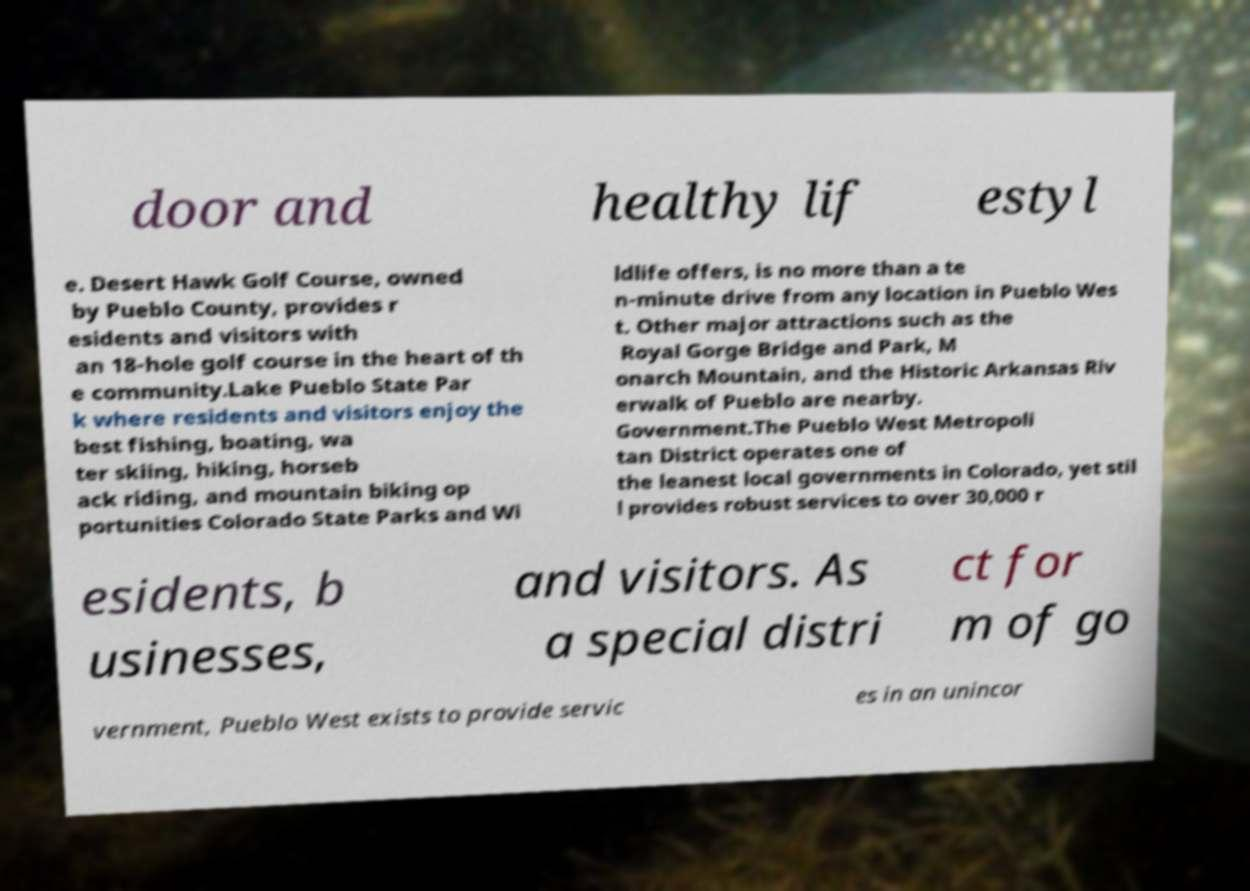What messages or text are displayed in this image? I need them in a readable, typed format. door and healthy lif estyl e. Desert Hawk Golf Course, owned by Pueblo County, provides r esidents and visitors with an 18-hole golf course in the heart of th e community.Lake Pueblo State Par k where residents and visitors enjoy the best fishing, boating, wa ter skiing, hiking, horseb ack riding, and mountain biking op portunities Colorado State Parks and Wi ldlife offers, is no more than a te n-minute drive from any location in Pueblo Wes t. Other major attractions such as the Royal Gorge Bridge and Park, M onarch Mountain, and the Historic Arkansas Riv erwalk of Pueblo are nearby. Government.The Pueblo West Metropoli tan District operates one of the leanest local governments in Colorado, yet stil l provides robust services to over 30,000 r esidents, b usinesses, and visitors. As a special distri ct for m of go vernment, Pueblo West exists to provide servic es in an unincor 